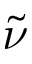<formula> <loc_0><loc_0><loc_500><loc_500>\tilde { \nu }</formula> 